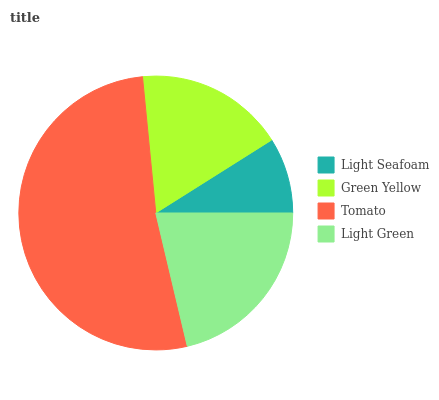Is Light Seafoam the minimum?
Answer yes or no. Yes. Is Tomato the maximum?
Answer yes or no. Yes. Is Green Yellow the minimum?
Answer yes or no. No. Is Green Yellow the maximum?
Answer yes or no. No. Is Green Yellow greater than Light Seafoam?
Answer yes or no. Yes. Is Light Seafoam less than Green Yellow?
Answer yes or no. Yes. Is Light Seafoam greater than Green Yellow?
Answer yes or no. No. Is Green Yellow less than Light Seafoam?
Answer yes or no. No. Is Light Green the high median?
Answer yes or no. Yes. Is Green Yellow the low median?
Answer yes or no. Yes. Is Green Yellow the high median?
Answer yes or no. No. Is Light Seafoam the low median?
Answer yes or no. No. 